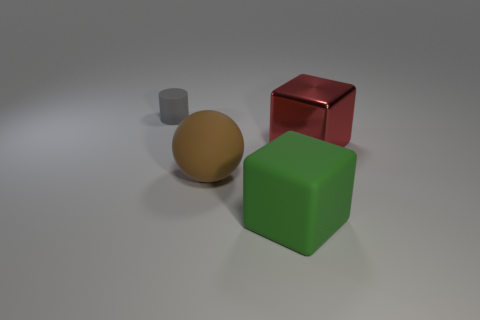Add 1 green matte things. How many objects exist? 5 Subtract all cylinders. How many objects are left? 3 Subtract all big brown cylinders. Subtract all green objects. How many objects are left? 3 Add 3 brown spheres. How many brown spheres are left? 4 Add 1 brown things. How many brown things exist? 2 Subtract 0 red cylinders. How many objects are left? 4 